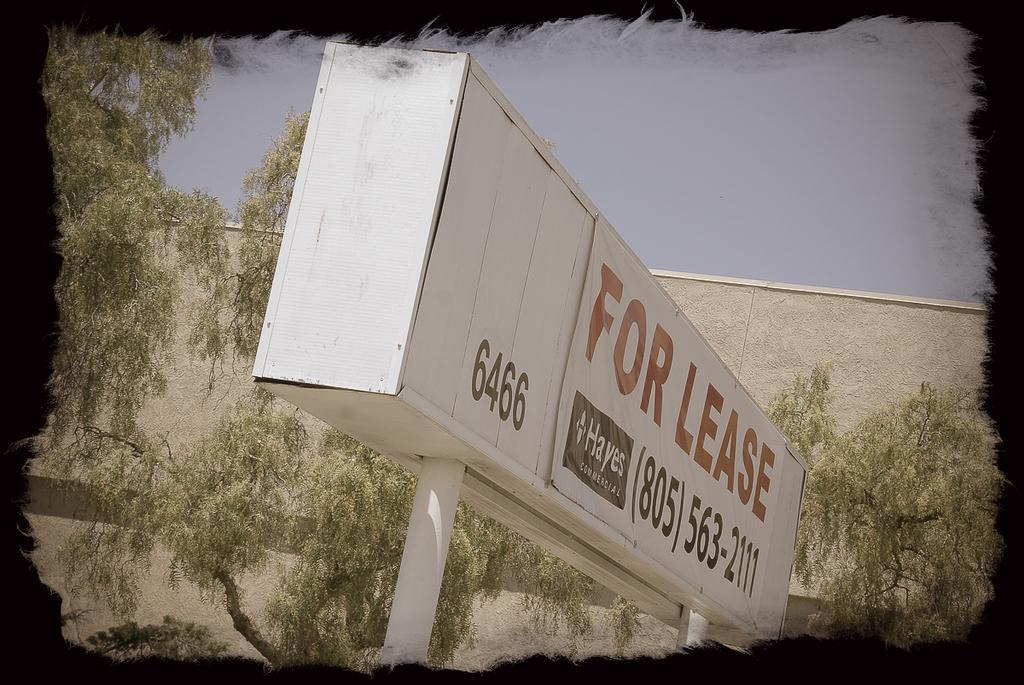Could you give a brief overview of what you see in this image? In this picture we can see advertisement board which is made from steel. On that we can see banner. In the background we can see many trees near to the wall. At the top there is a sky. 